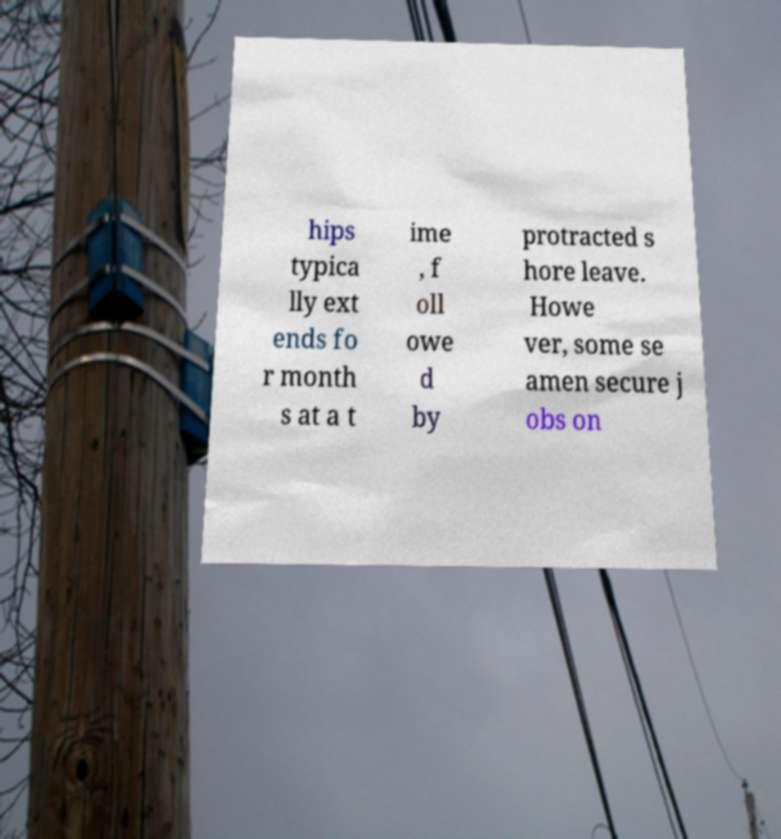Can you accurately transcribe the text from the provided image for me? hips typica lly ext ends fo r month s at a t ime , f oll owe d by protracted s hore leave. Howe ver, some se amen secure j obs on 